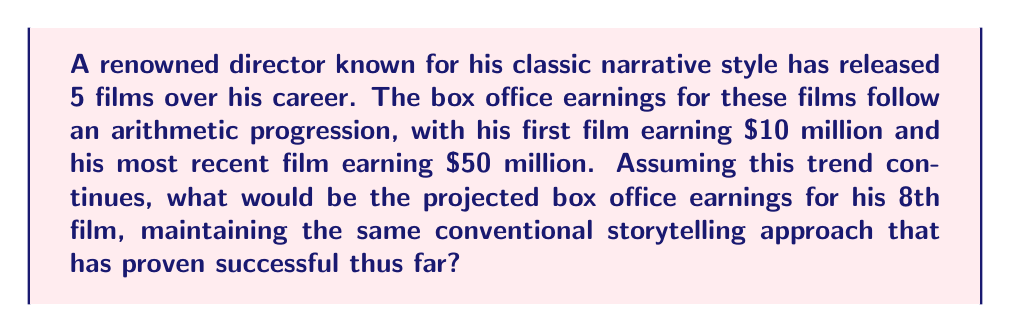Show me your answer to this math problem. Let's approach this step-by-step using the principles of arithmetic progression:

1) We know that the first term $a_1 = 10$ million and the fifth term $a_5 = 50$ million.

2) In an arithmetic progression, the difference between each term is constant. Let's call this common difference $d$. We can find $d$ using the formula:

   $a_n = a_1 + (n-1)d$

   Where $a_n$ is the nth term, $a_1$ is the first term, $n$ is the position of the term, and $d$ is the common difference.

3) Substituting our known values:

   $50 = 10 + (5-1)d$
   $50 = 10 + 4d$
   $40 = 4d$
   $d = 10$

4) Now that we know the common difference, we can use the same formula to find the 8th term:

   $a_8 = a_1 + (8-1)d$
   $a_8 = 10 + (7)(10)$
   $a_8 = 10 + 70$
   $a_8 = 80$

Therefore, maintaining the same progression, the 8th film would be projected to earn $80 million at the box office.
Answer: $80 million 